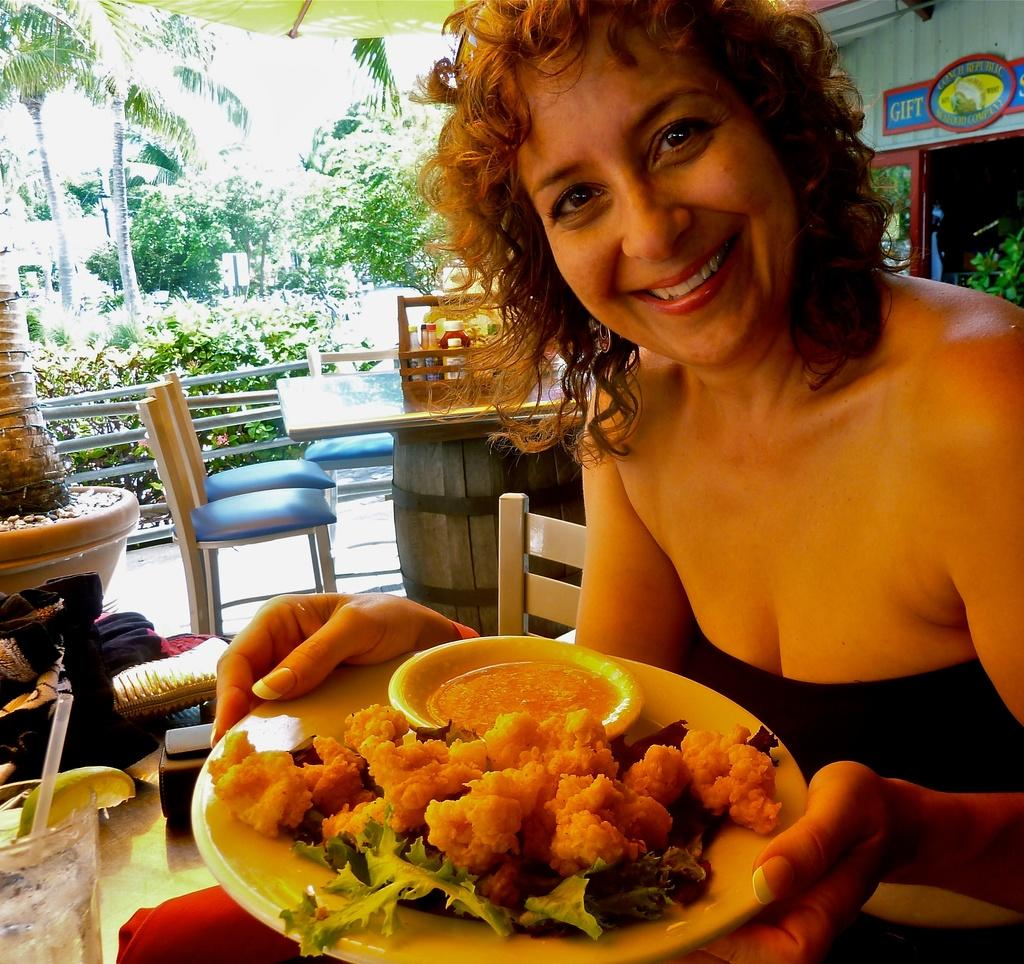Who is the main subject in the picture? There is a woman in the picture. What is the woman doing in the image? The woman is sitting and smiling. What is the woman holding in the image? The woman has a plate in her hands. What is on the plate that the woman is holding? There is food on the plate. Can you see the woman's toe in the image? There is no indication of the woman's toe in the image. Is there a doll present at the party in the image? There is no mention of a party or a doll in the image; it only features a woman holding a plate with food. 